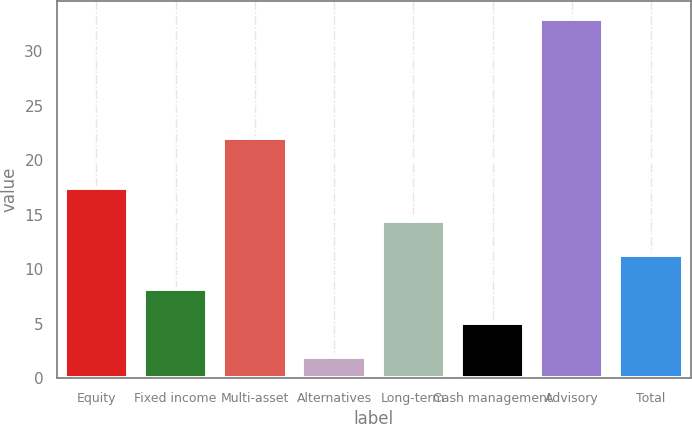Convert chart to OTSL. <chart><loc_0><loc_0><loc_500><loc_500><bar_chart><fcel>Equity<fcel>Fixed income<fcel>Multi-asset<fcel>Alternatives<fcel>Long-term<fcel>Cash management<fcel>Advisory<fcel>Total<nl><fcel>17.5<fcel>8.2<fcel>22<fcel>2<fcel>14.4<fcel>5.1<fcel>33<fcel>11.3<nl></chart> 